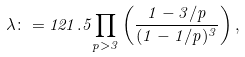<formula> <loc_0><loc_0><loc_500><loc_500>\lambda \colon = { 1 2 1 . 5 } { \prod _ { p > 3 } } \left ( \frac { 1 - { 3 / p } } { ( 1 - { 1 / p } ) ^ { 3 } } \right ) ,</formula> 